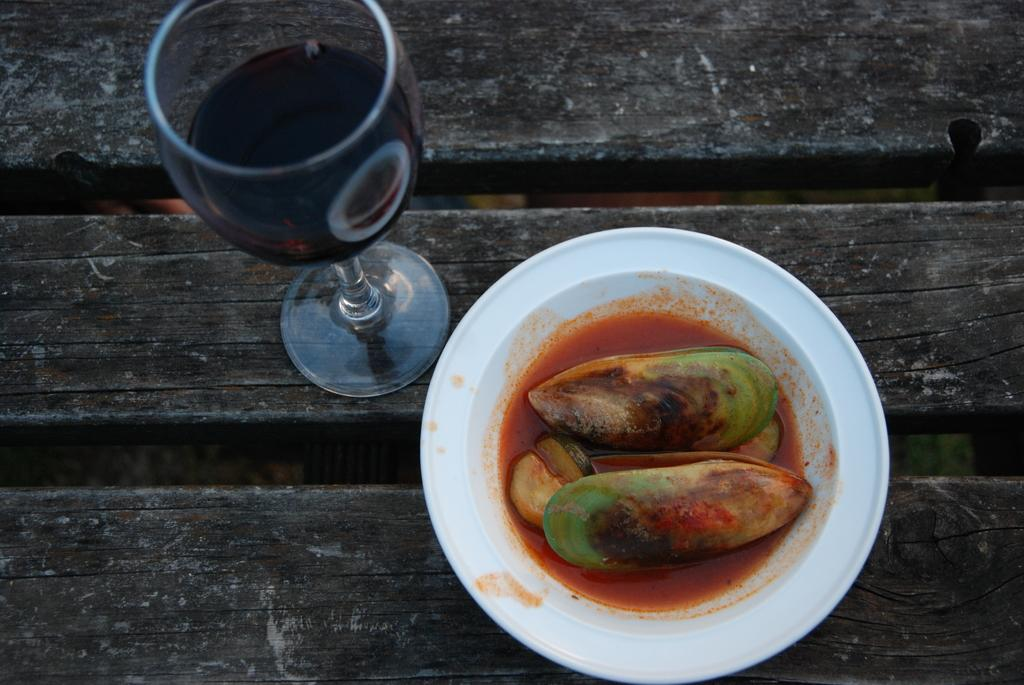What type of food is in the serving plate in the image? The specific type of food cannot be determined from the image, but there is food in a serving plate. What is the beverage in the tumbler in the image? The specific type of beverage cannot be determined from the image, but there is a beverage in a tumbler. What material is the surface on which the food and beverage are placed? The surface is made of wood. What type of treatment is being administered to the wooden surface in the image? There is no treatment being administered to the wooden surface in the image; it is simply a surface for the food and beverage. 